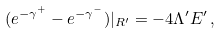Convert formula to latex. <formula><loc_0><loc_0><loc_500><loc_500>( e ^ { - \gamma ^ { + } } - e ^ { - \gamma ^ { - } } ) | _ { R ^ { \prime } } = - 4 \Lambda ^ { \prime } E ^ { \prime } \, ,</formula> 